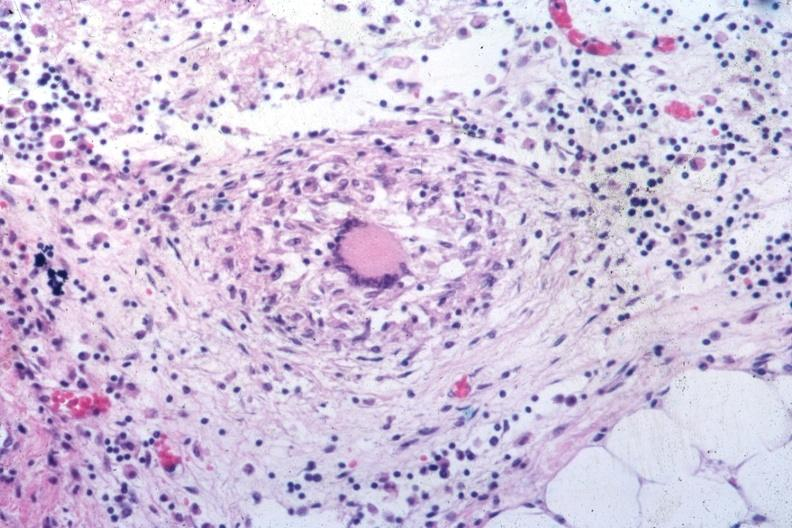what seen at low classical granuloma with langhans giant cell?
Answer the question using a single word or phrase. Outstanding example of a tubercular same as in slide 